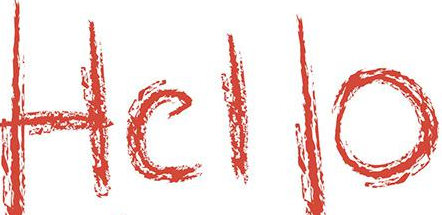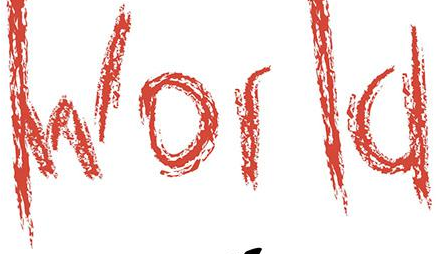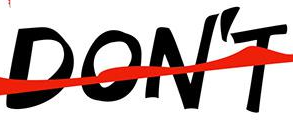Read the text from these images in sequence, separated by a semicolon. Hello; World; DON'T 